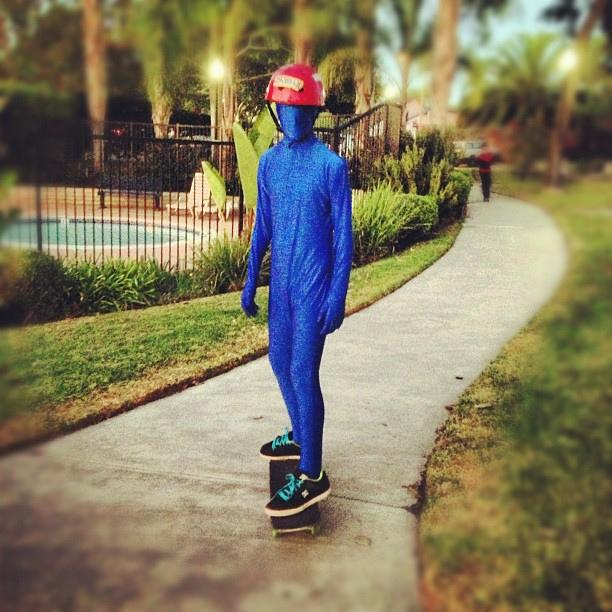What important property does this blue outfit have? Please explain your reasoning. breathable. Since the person's face is covered they need breathable material in order to wear the costume very long. 